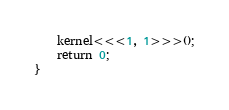Convert code to text. <code><loc_0><loc_0><loc_500><loc_500><_Cuda_>    kernel<<<1, 1>>>();
    return 0;
}
</code> 